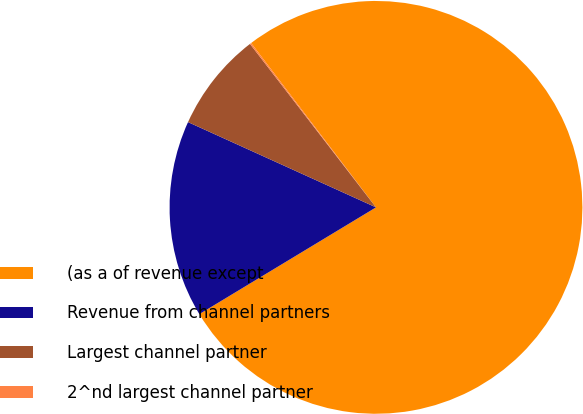Convert chart to OTSL. <chart><loc_0><loc_0><loc_500><loc_500><pie_chart><fcel>(as a of revenue except<fcel>Revenue from channel partners<fcel>Largest channel partner<fcel>2^nd largest channel partner<nl><fcel>76.69%<fcel>15.43%<fcel>7.77%<fcel>0.11%<nl></chart> 